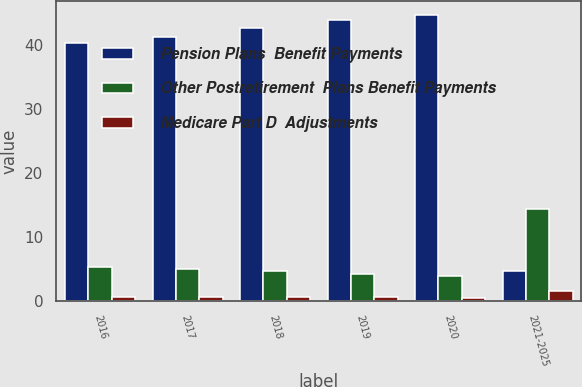Convert chart. <chart><loc_0><loc_0><loc_500><loc_500><stacked_bar_chart><ecel><fcel>2016<fcel>2017<fcel>2018<fcel>2019<fcel>2020<fcel>2021-2025<nl><fcel>Pension Plans  Benefit Payments<fcel>40.3<fcel>41.2<fcel>42.6<fcel>43.8<fcel>44.6<fcel>4.7<nl><fcel>Other Postretirement  Plans Benefit Payments<fcel>5.2<fcel>5<fcel>4.7<fcel>4.2<fcel>3.9<fcel>14.3<nl><fcel>Medicare Part D  Adjustments<fcel>0.6<fcel>0.6<fcel>0.5<fcel>0.5<fcel>0.4<fcel>1.5<nl></chart> 